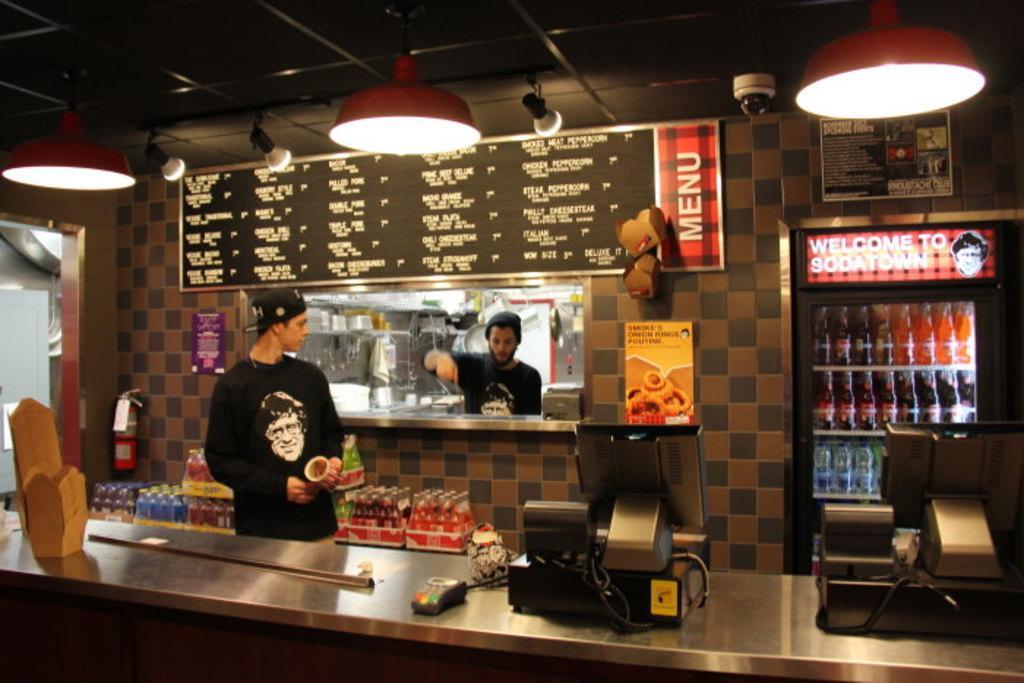How would you summarize this image in a sentence or two? In this image we can see the inner view of a store. In this image we can see some drinks, a person and other objects. In the background of the image there is a person, refrigerator with some drinks, wall and some other objects. At the top of the image of the image there is the ceiling with lights. At the bottom of the image there are some objects. 